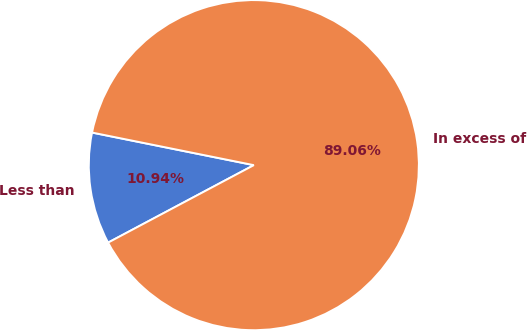<chart> <loc_0><loc_0><loc_500><loc_500><pie_chart><fcel>Less than<fcel>In excess of<nl><fcel>10.94%<fcel>89.06%<nl></chart> 